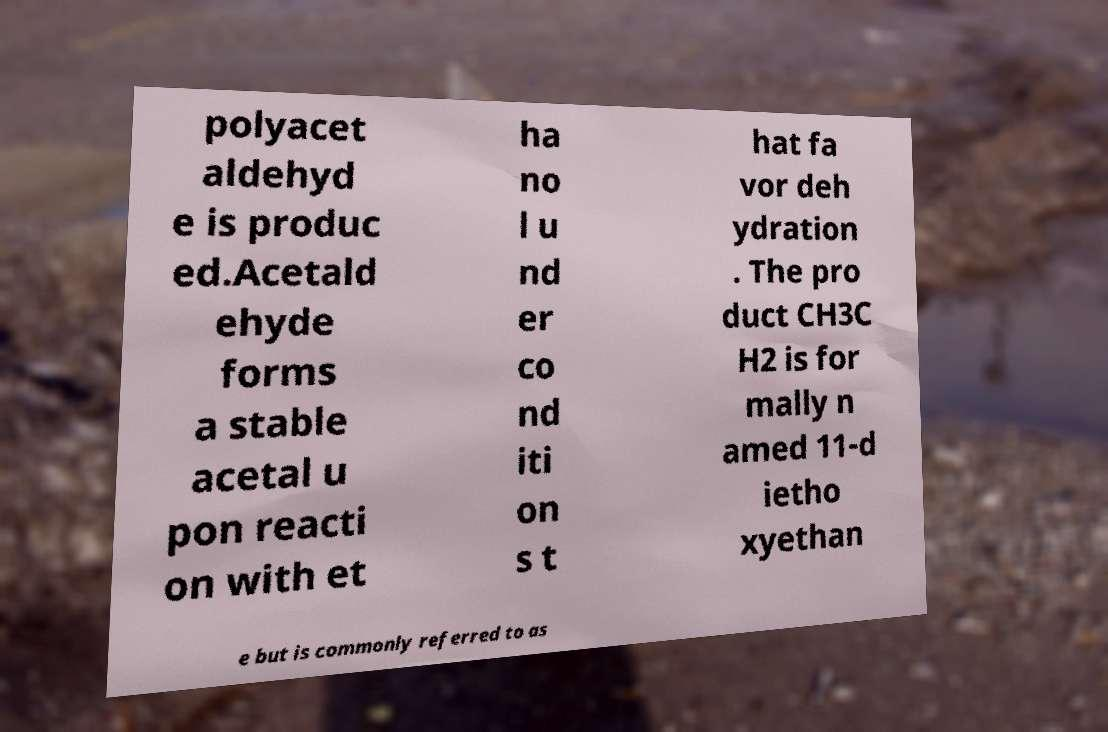Can you read and provide the text displayed in the image?This photo seems to have some interesting text. Can you extract and type it out for me? polyacet aldehyd e is produc ed.Acetald ehyde forms a stable acetal u pon reacti on with et ha no l u nd er co nd iti on s t hat fa vor deh ydration . The pro duct CH3C H2 is for mally n amed 11-d ietho xyethan e but is commonly referred to as 